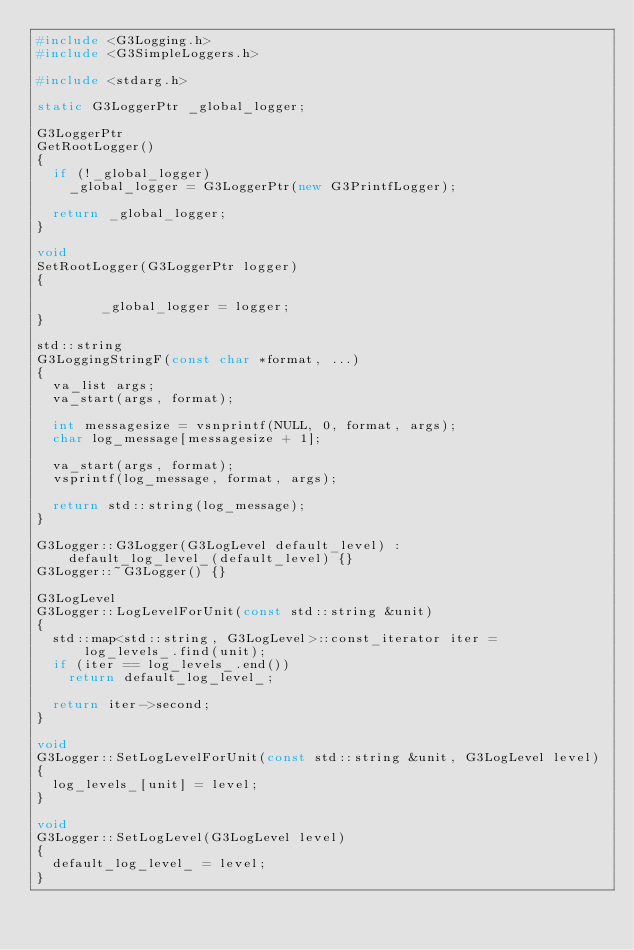Convert code to text. <code><loc_0><loc_0><loc_500><loc_500><_C++_>#include <G3Logging.h>
#include <G3SimpleLoggers.h>

#include <stdarg.h>

static G3LoggerPtr _global_logger;

G3LoggerPtr
GetRootLogger()
{
	if (!_global_logger)
		_global_logger = G3LoggerPtr(new G3PrintfLogger);

	return _global_logger;
}

void
SetRootLogger(G3LoggerPtr logger)
{

        _global_logger = logger;
}

std::string
G3LoggingStringF(const char *format, ...)
{
	va_list args;
	va_start(args, format);

	int messagesize = vsnprintf(NULL, 0, format, args);
	char log_message[messagesize + 1];

	va_start(args, format);
	vsprintf(log_message, format, args);

	return std::string(log_message);
}

G3Logger::G3Logger(G3LogLevel default_level) :
    default_log_level_(default_level) {}
G3Logger::~G3Logger() {}

G3LogLevel
G3Logger::LogLevelForUnit(const std::string &unit)
{
	std::map<std::string, G3LogLevel>::const_iterator iter =
	    log_levels_.find(unit);
	if (iter == log_levels_.end())
		return default_log_level_;

	return iter->second;
}

void
G3Logger::SetLogLevelForUnit(const std::string &unit, G3LogLevel level)
{
	log_levels_[unit] = level;
}

void
G3Logger::SetLogLevel(G3LogLevel level)
{
	default_log_level_ = level;
}
</code> 